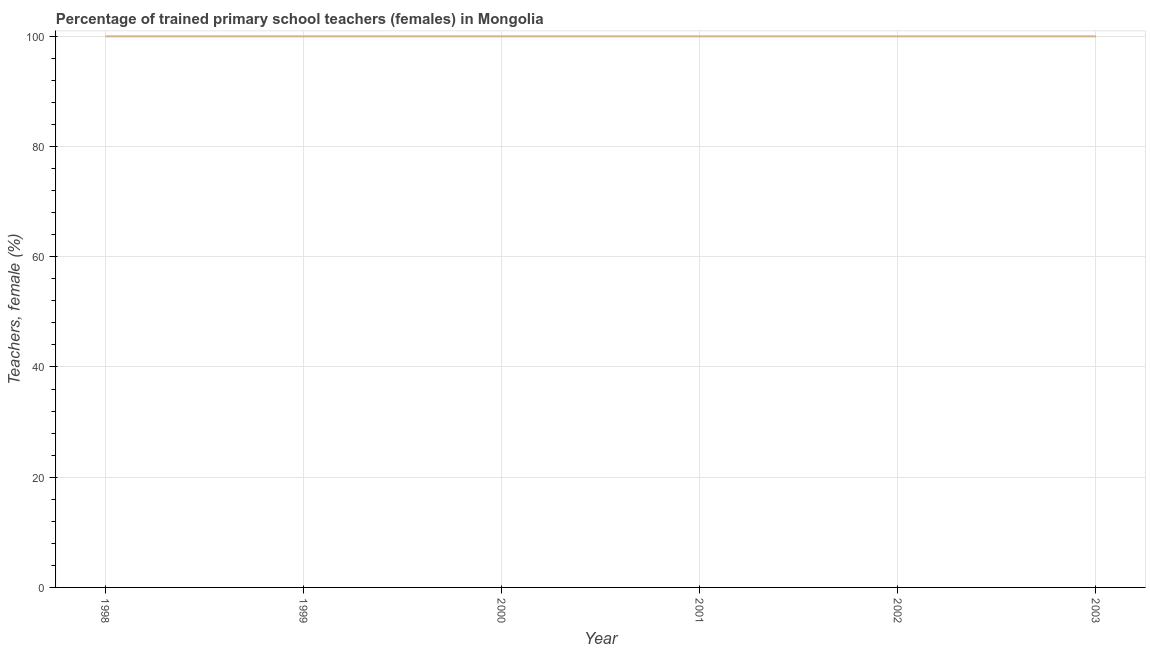Across all years, what is the minimum percentage of trained female teachers?
Provide a short and direct response. 100. What is the sum of the percentage of trained female teachers?
Your response must be concise. 600. What is the difference between the percentage of trained female teachers in 2001 and 2002?
Your answer should be very brief. 0. What is the average percentage of trained female teachers per year?
Your response must be concise. 100. What is the median percentage of trained female teachers?
Give a very brief answer. 100. Do a majority of the years between 2001 and 2003 (inclusive) have percentage of trained female teachers greater than 8 %?
Offer a terse response. Yes. What is the ratio of the percentage of trained female teachers in 1998 to that in 2001?
Keep it short and to the point. 1. Is the percentage of trained female teachers in 2001 less than that in 2002?
Provide a succinct answer. No. Is the difference between the percentage of trained female teachers in 1999 and 2002 greater than the difference between any two years?
Provide a succinct answer. Yes. In how many years, is the percentage of trained female teachers greater than the average percentage of trained female teachers taken over all years?
Provide a short and direct response. 0. How many years are there in the graph?
Give a very brief answer. 6. What is the difference between two consecutive major ticks on the Y-axis?
Your response must be concise. 20. Are the values on the major ticks of Y-axis written in scientific E-notation?
Give a very brief answer. No. Does the graph contain any zero values?
Your answer should be compact. No. Does the graph contain grids?
Your answer should be compact. Yes. What is the title of the graph?
Your answer should be very brief. Percentage of trained primary school teachers (females) in Mongolia. What is the label or title of the X-axis?
Provide a short and direct response. Year. What is the label or title of the Y-axis?
Make the answer very short. Teachers, female (%). What is the Teachers, female (%) in 1998?
Make the answer very short. 100. What is the Teachers, female (%) of 1999?
Your answer should be very brief. 100. What is the Teachers, female (%) in 2001?
Make the answer very short. 100. What is the Teachers, female (%) in 2002?
Your response must be concise. 100. What is the difference between the Teachers, female (%) in 1998 and 1999?
Offer a terse response. 0. What is the difference between the Teachers, female (%) in 1998 and 2000?
Your answer should be very brief. 0. What is the difference between the Teachers, female (%) in 1999 and 2002?
Give a very brief answer. 0. What is the ratio of the Teachers, female (%) in 1998 to that in 2001?
Keep it short and to the point. 1. What is the ratio of the Teachers, female (%) in 2000 to that in 2001?
Provide a short and direct response. 1. What is the ratio of the Teachers, female (%) in 2000 to that in 2002?
Your response must be concise. 1. 